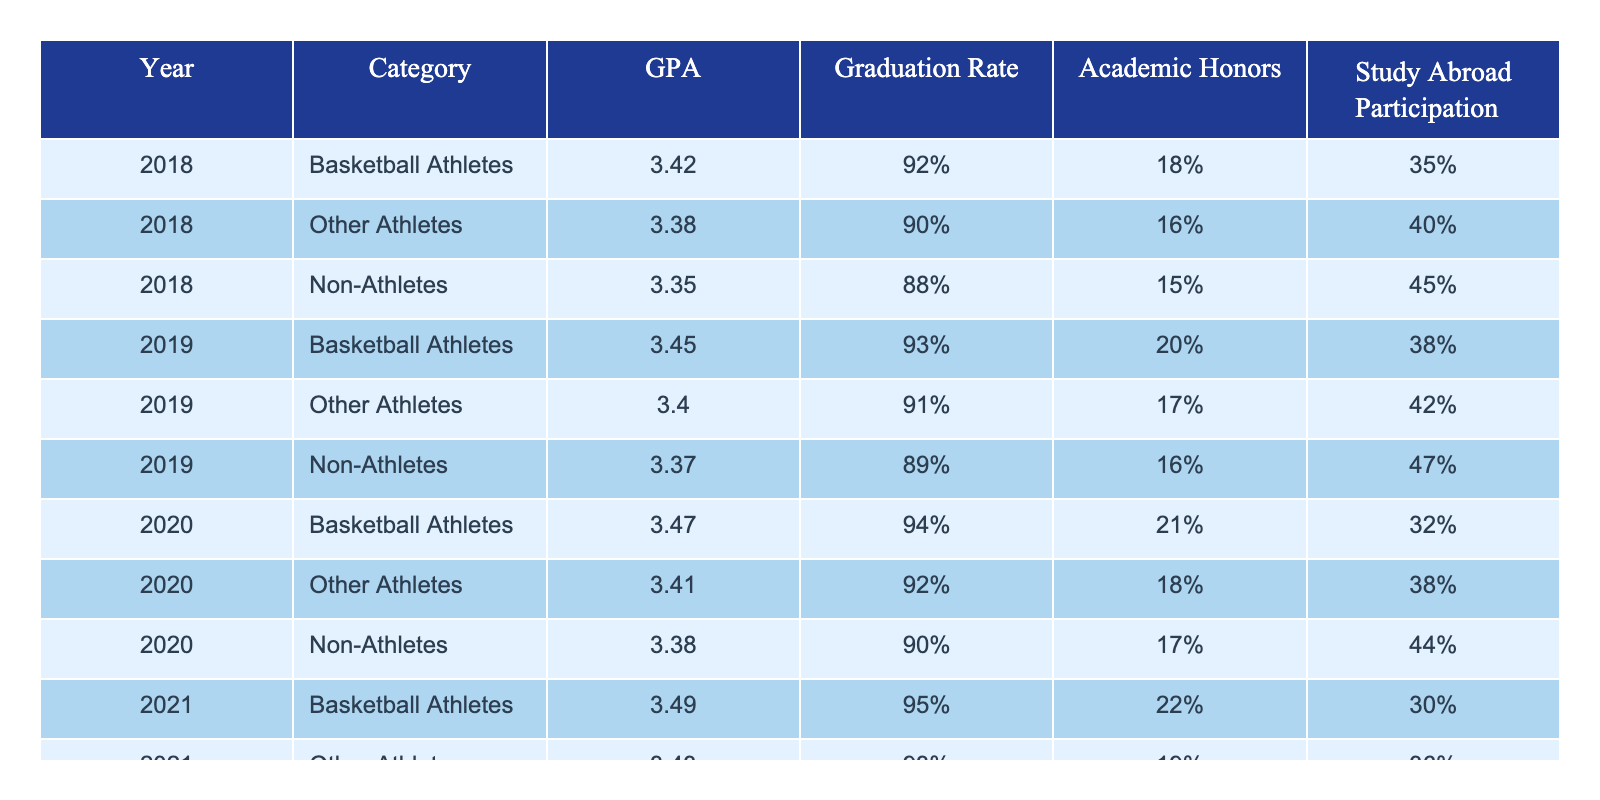What was the GPA of Basketball Athletes in 2021? Looking at the table for the year 2021 under the "GPA" column for "Basketball Athletes," the value is 3.49.
Answer: 3.49 What is the Graduation Rate of Non-Athletes in 2018? Referring to the table, the Graduation Rate for Non-Athletes in 2018 is 88%.
Answer: 88% Which group had the highest average GPA across all years? We sum the GPAs for each category over the years: Basketball Athletes = (3.42 + 3.45 + 3.47 + 3.49) = 13.83; Other Athletes = (3.38 + 3.40 + 3.41 + 3.43) = 13.62; Non-Athletes = (3.35 + 3.37 + 3.38 + 3.39) = 13.49. Dividing these sums by respective years (4), Basketball Athletes have the highest average with 3.46.
Answer: Basketball Athletes What is the difference in Graduation Rates between Other Athletes and Non-Athletes in 2020? In 2020, the Graduation Rate for Other Athletes is 92%, while for Non-Athletes it is 90%. The difference is 92% - 90% = 2%.
Answer: 2% Did the GPA of Non-Athletes increase from 2018 to 2021? Looking at the GPAs for Non-Athletes: 2018 is 3.35 and 2021 is 3.39. Since 3.39 is greater than 3.35, yes, the GPA has increased.
Answer: Yes What was the total percentage of Study Abroad Participation for Basketball Athletes from 2018 to 2021? For Basketball Athletes, the Study Abroad Percentages are 18% (2018) + 20% (2019) + 21% (2020) + 22% (2021) = 81%.
Answer: 81% Which category had the lowest average Graduation Rate, and what was it? Graduation Rates: Basketball Athletes average = 92%, Other Athletes average = 91.5%, Non-Athletes average = 90%. Non-Athletes have the lowest average Graduation Rate of 90%.
Answer: Non-Athletes, 90% How much did the Study Abroad Participation for Other Athletes decrease from 2018 to 2021? In 2018, Other Athletes had 40% Study Abroad Participation and in 2021 it dropped to 36%. Therefore, the decrease is 40% - 36% = 4%.
Answer: 4% Which year saw the highest GPA for Non-Athletes? Checking the GPAs for Non-Athletes, we have 3.35 (2018), 3.37 (2019), 3.38 (2020), and 3.39 (2021). The highest GPA is 3.39 in 2021.
Answer: 2021 Was the proportion of Academic Honors higher for Basketball Athletes or Other Athletes in 2019? In 2019, Basketball Athletes had 20% Academic Honors and Other Athletes had 17%. Since 20% is greater than 17%, Basketball Athletes had a higher proportion.
Answer: Basketball Athletes 